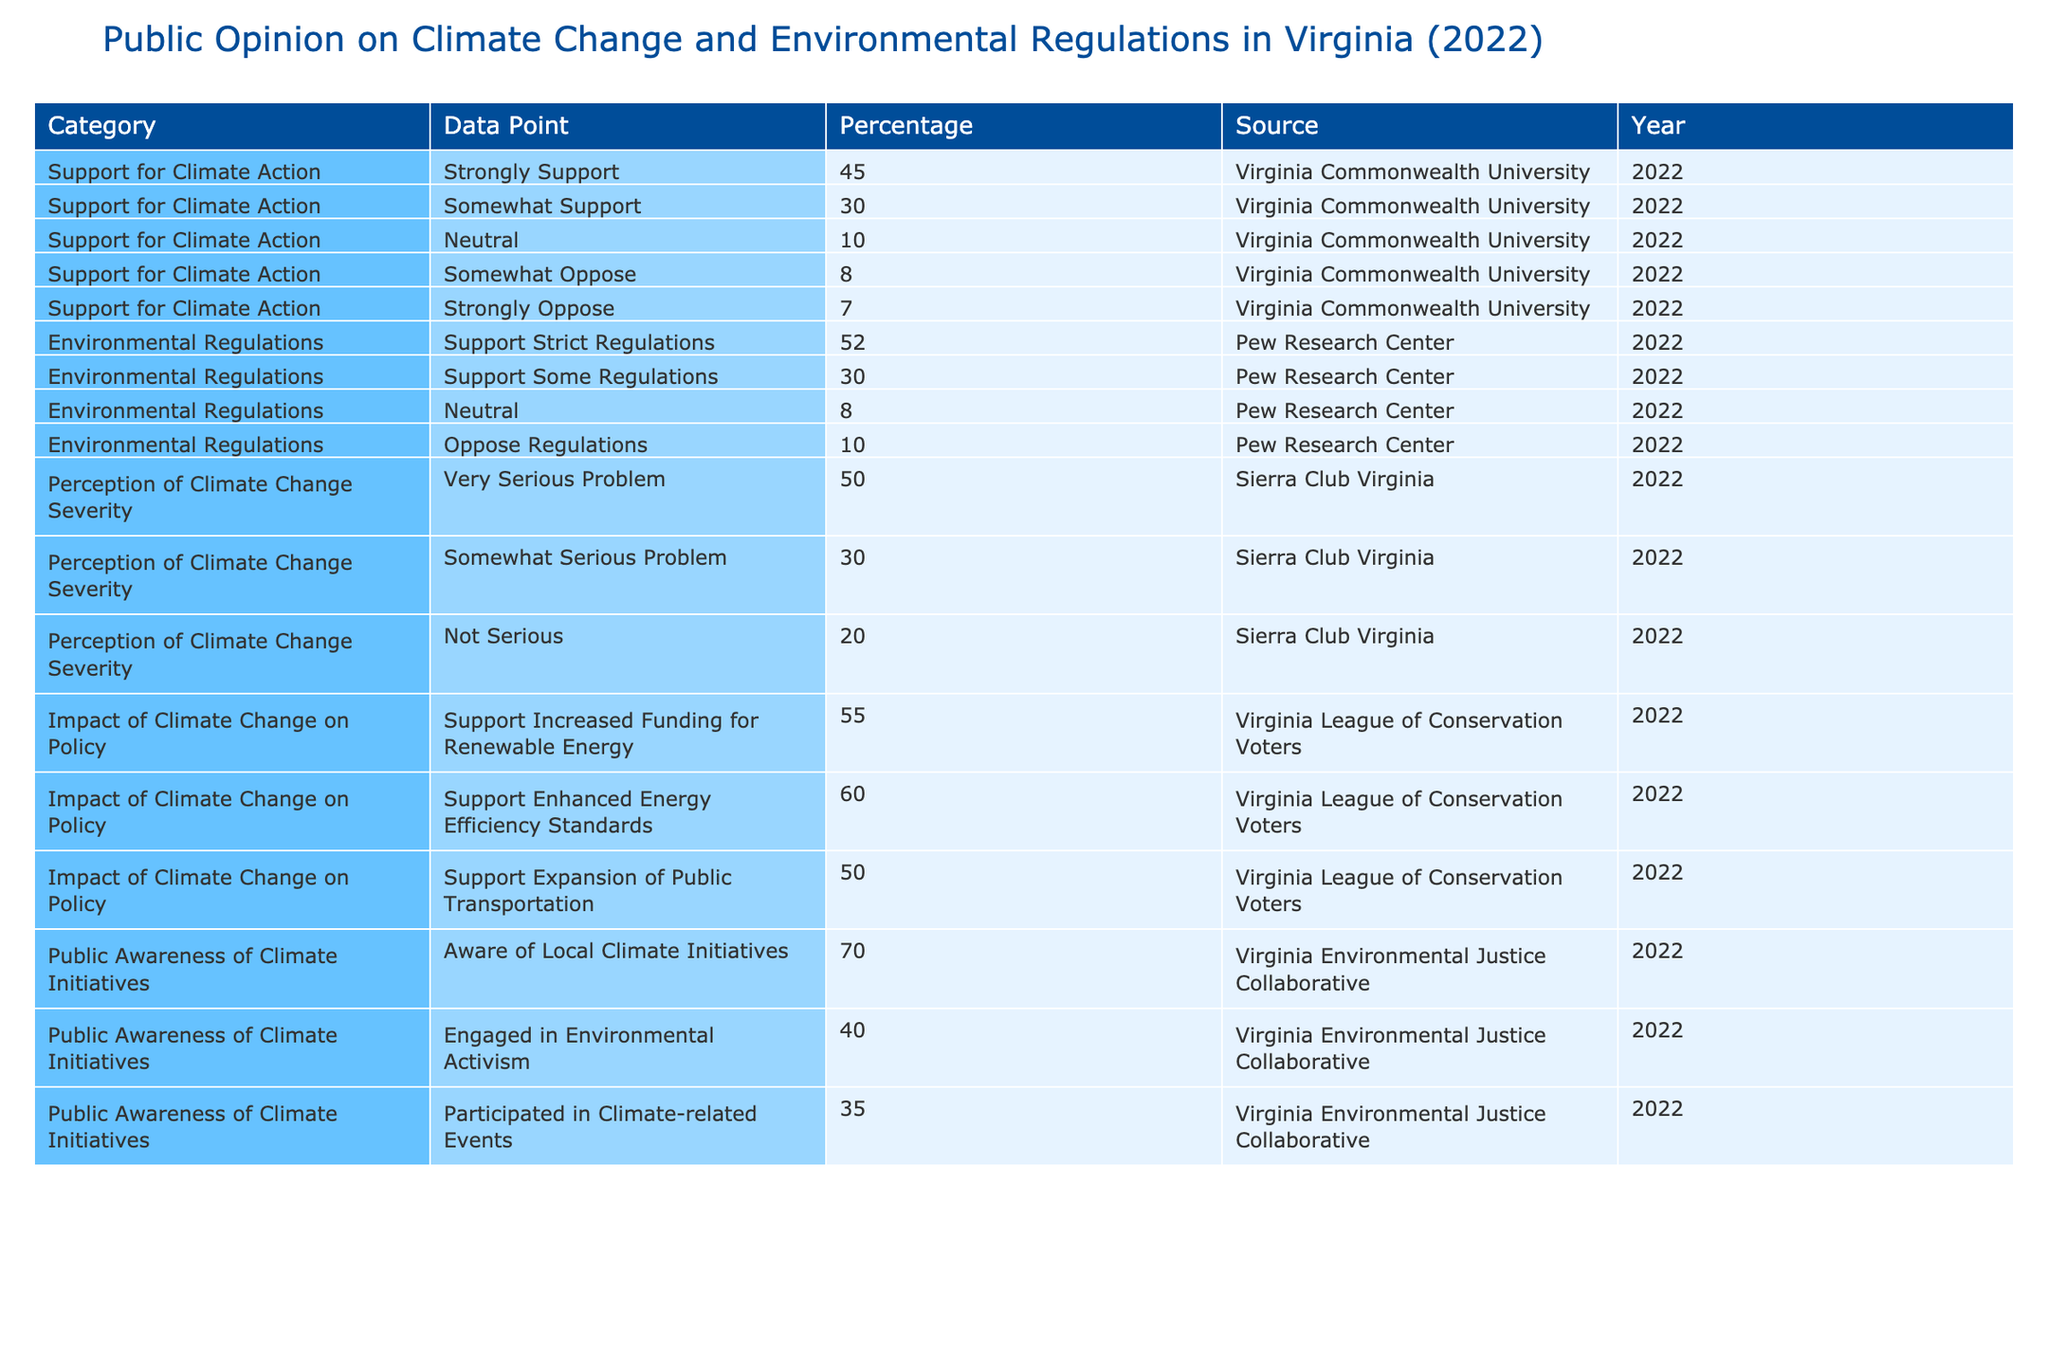What percentage of Virginians strongly support climate action? The table shows that 45% of respondents indicated they strongly support climate action according to Virginia Commonwealth University in 2022.
Answer: 45% What is the total percentage of Virginians who support climate action (strongly and somewhat)? To find this, we add the percentages for "Strongly Support" (45%) and "Somewhat Support" (30%), resulting in 45% + 30% = 75%.
Answer: 75% What percentage of people oppose environmental regulations in Virginia? The table indicates that 10% of respondents oppose regulations and 8% somewhat oppose, totaling 18%.
Answer: 18% Is it true that more people support strict environmental regulations than those who oppose them? Yes, 52% support strict regulations while 18% (10% oppose + 8% somewhat oppose) oppose, which confirms that support exceeds opposition.
Answer: Yes What percentage of respondents believe climate change is a very serious problem? According to the table, 50% of respondents perceive climate change as a very serious problem according to Sierra Club Virginia in 2022.
Answer: 50% How does the support for enhanced energy efficiency standards compare to the support for increased funding for renewable energy? Support for enhanced energy efficiency standards is at 60%, while support for increased funding for renewable energy is at 55%. Therefore, 60% - 55% shows a 5% higher support for efficiency standards.
Answer: 5% What percentage of people are engaged in environmental activism compared to those who are aware of local climate initiatives? Engagement in environmental activism is at 40% while awareness of local initiatives is at 70%. The difference is 70% - 40% = 30%.
Answer: 30% What is the percentage of those who participated in climate-related events compared to those who support some regulations? Participants in climate-related events represent 35%, while those who support some regulations represent 30%. Thus, 35% - 30% = 5% more participants than supporters of some regulations.
Answer: 5% Which category has the highest percentage of public awareness of climate initiatives? The table shows 70% awareness of local climate initiatives, which is higher than the percentages for engagement (40%) and participation (35%).
Answer: 70% If "Neutral" responses for climate action are combined with those opposing, what is the total percentage? We add the "Neutral" percentage (10%) to the sum of "Somewhat Oppose" (8%) and "Strongly Oppose" (7%), resulting in 10% + 8% + 7% = 25%.
Answer: 25% 